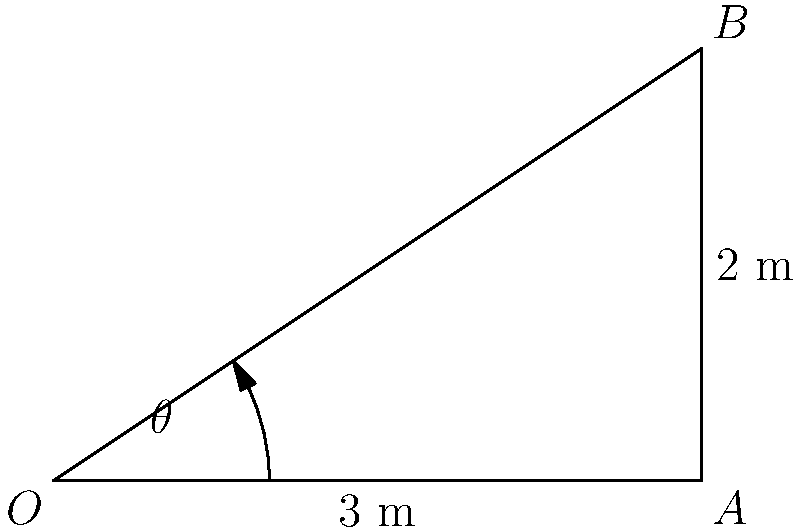In a state-of-the-art operating room, an adjustable operating table needs to be rotated to accommodate a patient with specific needs. The table's rotation mechanism forms a right-angled triangle, where the base of the triangle is 3 meters and the height is 2 meters, as shown in the diagram. Using inverse trigonometric functions, calculate the angle $\theta$ (in degrees) that the table needs to be rotated. Round your answer to the nearest degree. To solve this problem, we'll use the inverse tangent function (arctangent or $\tan^{-1}$) to find the angle $\theta$. Here's the step-by-step solution:

1) In a right-angled triangle, $\tan \theta = \frac{\text{opposite}}{\text{adjacent}}$

2) In this case:
   - The opposite side (height) is 2 meters
   - The adjacent side (base) is 3 meters

3) Therefore, $\tan \theta = \frac{2}{3}$

4) To find $\theta$, we need to use the inverse tangent function:
   $\theta = \tan^{-1}(\frac{2}{3})$

5) Using a calculator or computer:
   $\theta = \tan^{-1}(\frac{2}{3}) \approx 33.69°$

6) Rounding to the nearest degree:
   $\theta \approx 34°$

This angle represents the rotation needed for the operating table to achieve the specified position.
Answer: $34°$ 